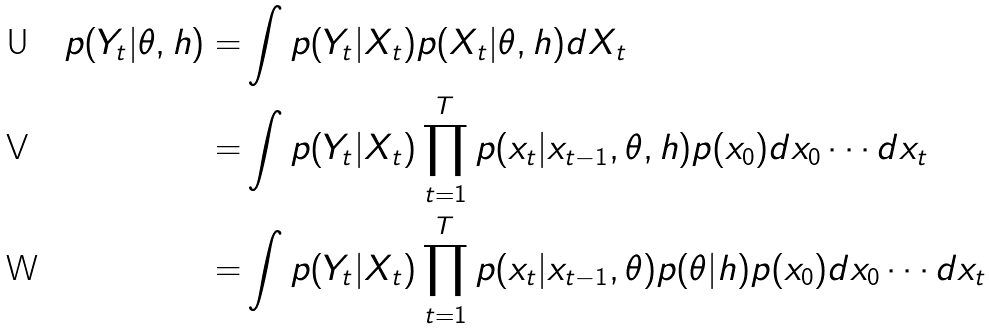<formula> <loc_0><loc_0><loc_500><loc_500>p ( Y _ { t } | \theta , h ) = & \int p ( Y _ { t } | X _ { t } ) p ( X _ { t } | \theta , h ) d X _ { t } \\ = & \int p ( Y _ { t } | X _ { t } ) \prod _ { t = 1 } ^ { T } p ( x _ { t } | x _ { t - 1 } , \theta , h ) p ( x _ { 0 } ) d x _ { 0 } \cdots d x _ { t } \\ = & \int p ( Y _ { t } | X _ { t } ) \prod _ { t = 1 } ^ { T } p ( x _ { t } | x _ { t - 1 } , \theta ) p ( \theta | h ) p ( x _ { 0 } ) d x _ { 0 } \cdots d x _ { t }</formula> 